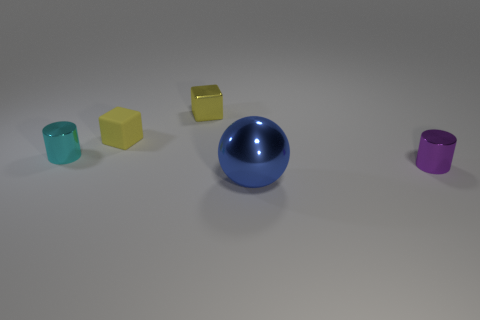Add 4 yellow metallic things. How many objects exist? 9 Subtract all balls. How many objects are left? 4 Add 2 tiny yellow matte blocks. How many tiny yellow matte blocks are left? 3 Add 1 cyan shiny objects. How many cyan shiny objects exist? 2 Subtract 0 red cylinders. How many objects are left? 5 Subtract all purple things. Subtract all small cylinders. How many objects are left? 2 